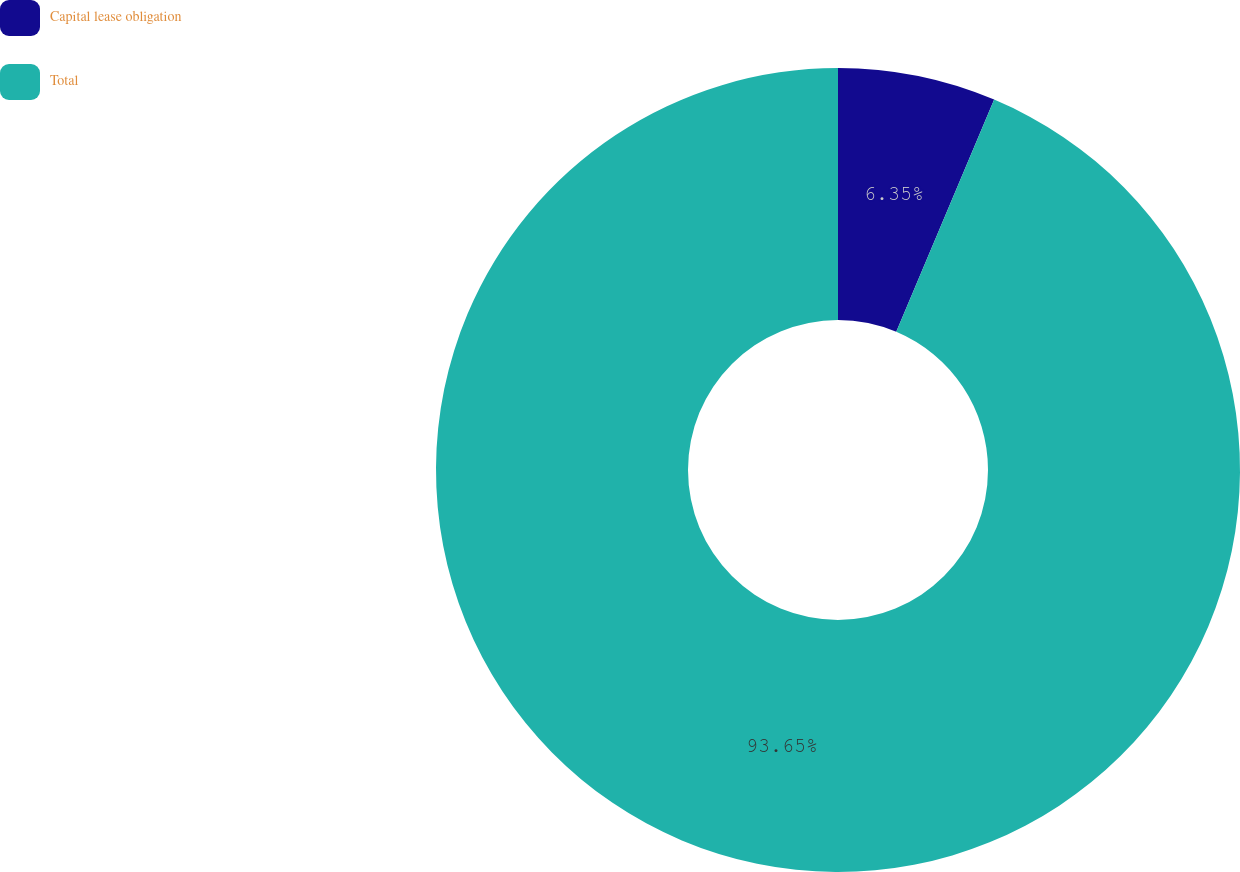<chart> <loc_0><loc_0><loc_500><loc_500><pie_chart><fcel>Capital lease obligation<fcel>Total<nl><fcel>6.35%<fcel>93.65%<nl></chart> 